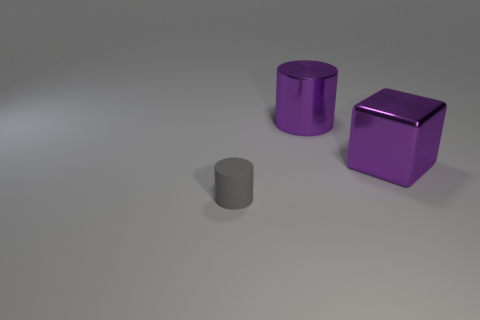Subtract 1 cubes. How many cubes are left? 0 Add 1 brown shiny things. How many objects exist? 4 Subtract all gray cylinders. How many cylinders are left? 1 Add 2 large gray matte spheres. How many large gray matte spheres exist? 2 Subtract 0 red spheres. How many objects are left? 3 Subtract all cubes. How many objects are left? 2 Subtract all blue cubes. Subtract all blue cylinders. How many cubes are left? 1 Subtract all brown blocks. How many cyan cylinders are left? 0 Subtract all small purple matte spheres. Subtract all matte objects. How many objects are left? 2 Add 3 big purple shiny cylinders. How many big purple shiny cylinders are left? 4 